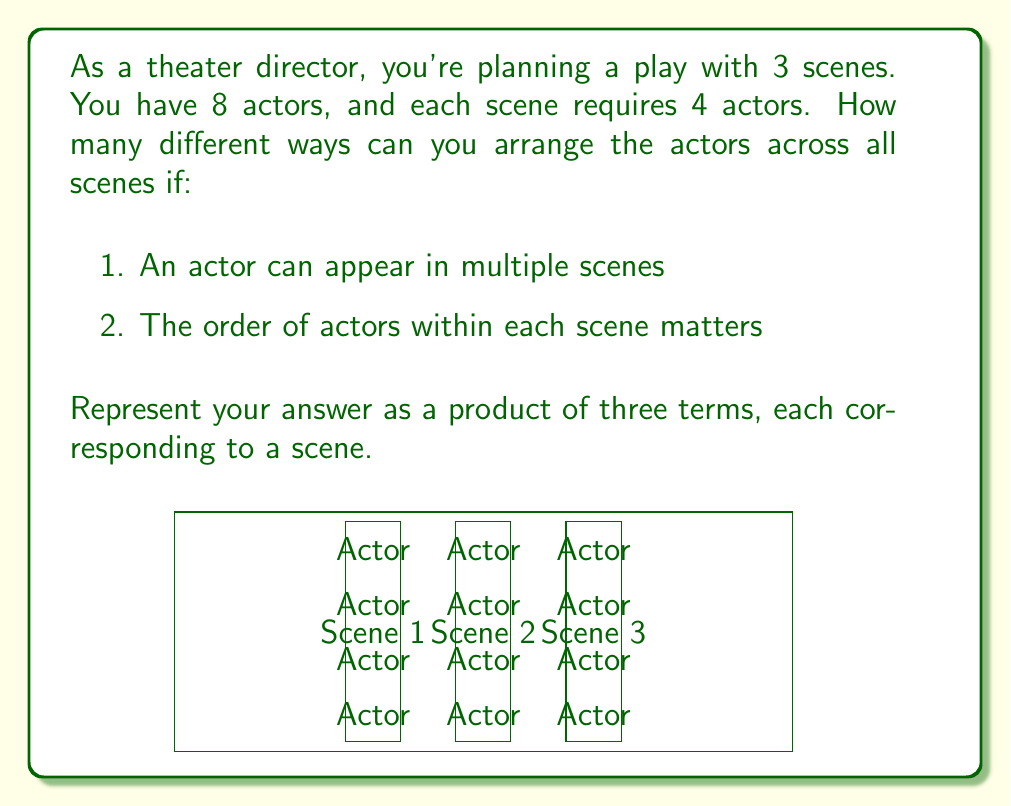Could you help me with this problem? Let's approach this step-by-step:

1) For each scene, we need to select 4 actors out of 8, and their order matters.

2) This is a permutation problem. We're selecting 4 actors out of 8, where order matters, and repetition is allowed (as actors can appear in multiple scenes).

3) For each scene, we have:
   - 8 choices for the first actor
   - 8 choices for the second actor (as an actor can be reused)
   - 8 choices for the third actor
   - 8 choices for the fourth actor

4) This gives us $8 \times 8 \times 8 \times 8 = 8^4$ possibilities for each scene.

5) We have 3 independent scenes, each with $8^4$ possibilities.

6) By the multiplication principle, the total number of ways to arrange actors across all scenes is:

   $$(8^4) \times (8^4) \times (8^4) = 8^4 \times 8^4 \times 8^4 = 8^{12}$$

This can be interpreted as:
- $8^4$ ways to arrange actors in the first scene
- $8^4$ ways to arrange actors in the second scene
- $8^4$ ways to arrange actors in the third scene
Answer: $8^4 \times 8^4 \times 8^4$ 